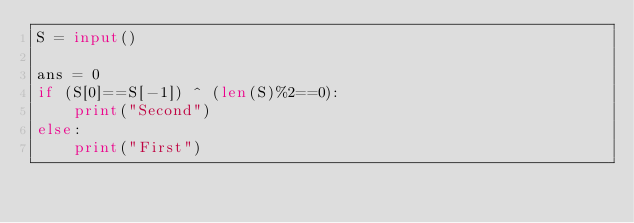<code> <loc_0><loc_0><loc_500><loc_500><_Python_>S = input()

ans = 0
if (S[0]==S[-1]) ^ (len(S)%2==0):
    print("Second")
else:
    print("First")</code> 